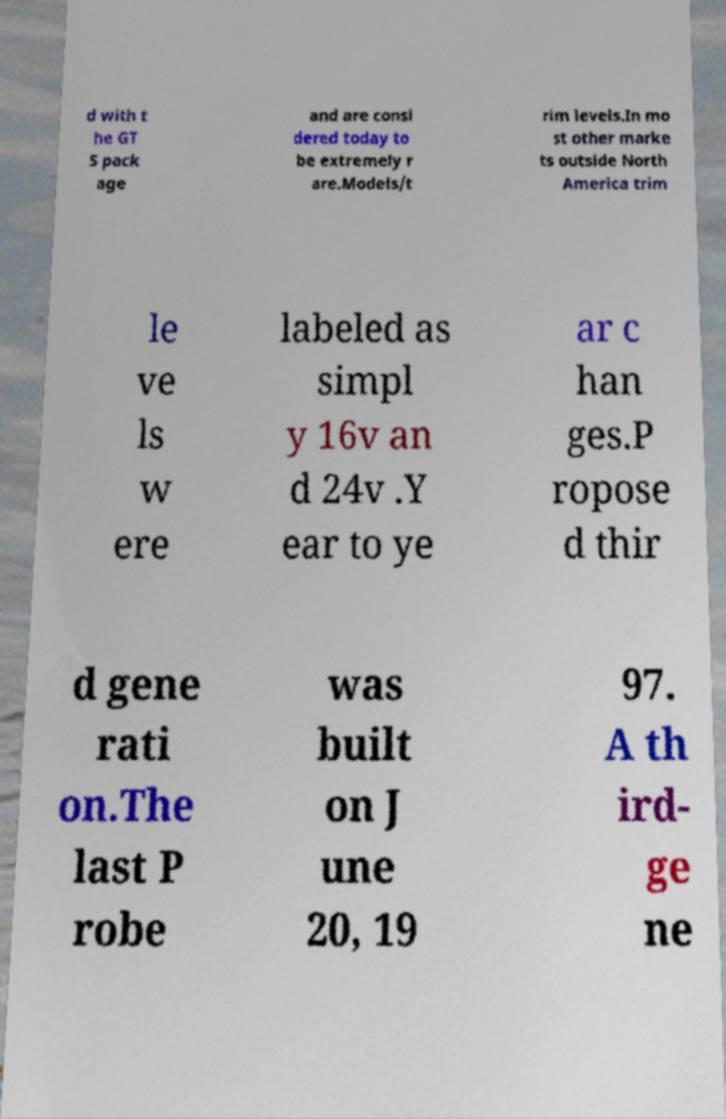Please read and relay the text visible in this image. What does it say? d with t he GT S pack age and are consi dered today to be extremely r are.Models/t rim levels.In mo st other marke ts outside North America trim le ve ls w ere labeled as simpl y 16v an d 24v .Y ear to ye ar c han ges.P ropose d thir d gene rati on.The last P robe was built on J une 20, 19 97. A th ird- ge ne 